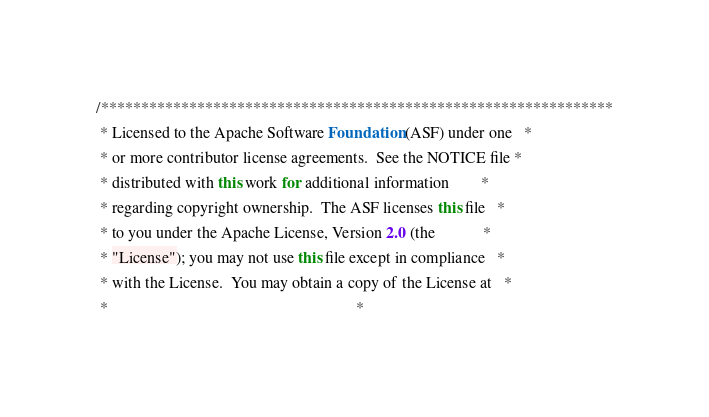Convert code to text. <code><loc_0><loc_0><loc_500><loc_500><_Java_>/****************************************************************
 * Licensed to the Apache Software Foundation (ASF) under one   *
 * or more contributor license agreements.  See the NOTICE file *
 * distributed with this work for additional information        *
 * regarding copyright ownership.  The ASF licenses this file   *
 * to you under the Apache License, Version 2.0 (the            *
 * "License"); you may not use this file except in compliance   *
 * with the License.  You may obtain a copy of the License at   *
 *                                                              *</code> 